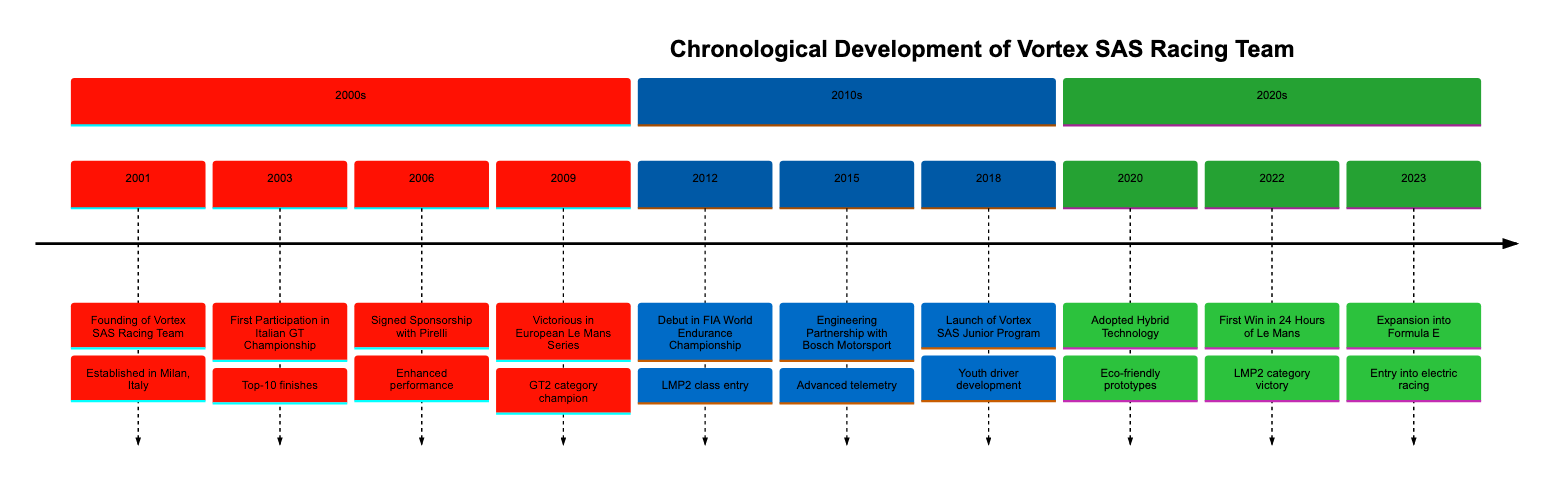What year was Vortex SAS Racing Team founded? The timeline shows that the founding event of Vortex SAS Racing Team occurred in the year 2001.
Answer: 2001 How many years after its founding did Vortex SAS Racing Team win its first championship? The first championship win in the European Le Mans Series was in 2009, which is 8 years after the founding in 2001.
Answer: 8 years What significant event occurred in 2006? The timeline specifies that in 2006, Vortex SAS Racing Team signed a sponsorship with Pirelli.
Answer: Signed Sponsorship with Pirelli In which category did Vortex SAS Racing Team achieve victory in the 24 Hours of Le Mans? According to the timeline, the victory in the 24 Hours of Le Mans was achieved in the LMP2 category in 2022.
Answer: LMP2 category What partnership was established in 2015? The timeline indicates that in 2015, Vortex SAS Racing Team partnered with Bosch Motorsport for engineering solutions.
Answer: Engineering Partnership with Bosch Motorsport Which event represents the team's expansion into electric racing? The timeline shows that in 2023, the team announced its entry into Formula E, marking their expansion into electric racing.
Answer: Expansion into Formula E What technological advancement did the team adopt in 2020? The timeline notes that in 2020, Vortex SAS Racing Team adopted hybrid technology for their new prototypes.
Answer: Hybrid Technology How many major events are listed in the timeline? By counting the events in the timeline, there are a total of 10 significant events listed from the founding in 2001 to the present.
Answer: 10 